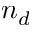<formula> <loc_0><loc_0><loc_500><loc_500>n _ { d }</formula> 